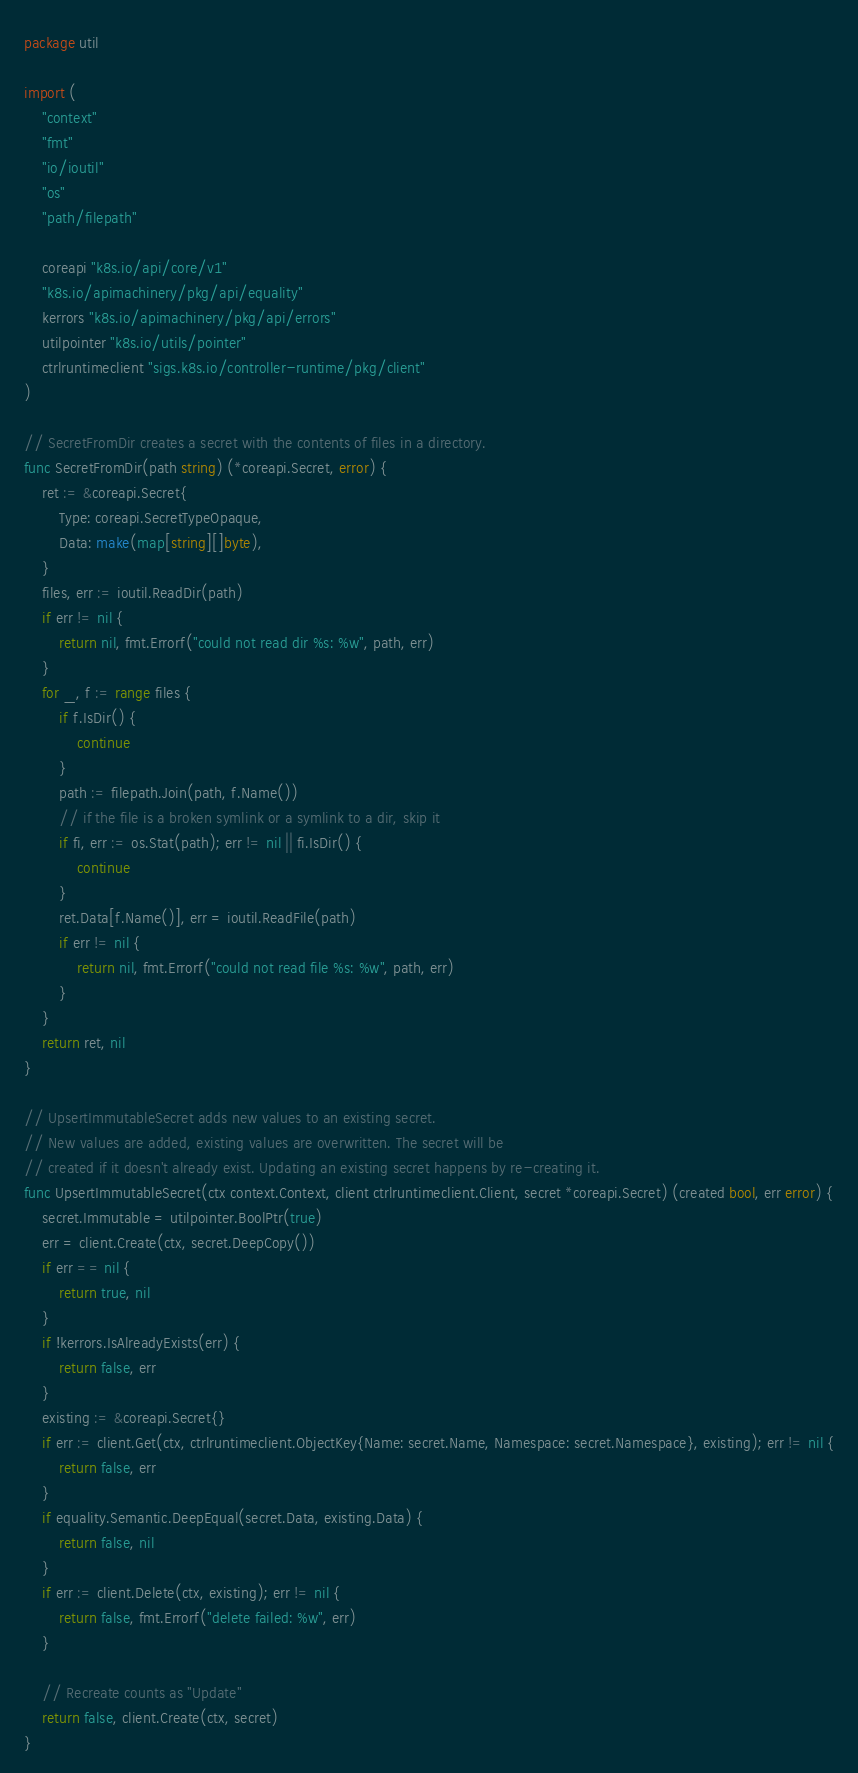Convert code to text. <code><loc_0><loc_0><loc_500><loc_500><_Go_>package util

import (
	"context"
	"fmt"
	"io/ioutil"
	"os"
	"path/filepath"

	coreapi "k8s.io/api/core/v1"
	"k8s.io/apimachinery/pkg/api/equality"
	kerrors "k8s.io/apimachinery/pkg/api/errors"
	utilpointer "k8s.io/utils/pointer"
	ctrlruntimeclient "sigs.k8s.io/controller-runtime/pkg/client"
)

// SecretFromDir creates a secret with the contents of files in a directory.
func SecretFromDir(path string) (*coreapi.Secret, error) {
	ret := &coreapi.Secret{
		Type: coreapi.SecretTypeOpaque,
		Data: make(map[string][]byte),
	}
	files, err := ioutil.ReadDir(path)
	if err != nil {
		return nil, fmt.Errorf("could not read dir %s: %w", path, err)
	}
	for _, f := range files {
		if f.IsDir() {
			continue
		}
		path := filepath.Join(path, f.Name())
		// if the file is a broken symlink or a symlink to a dir, skip it
		if fi, err := os.Stat(path); err != nil || fi.IsDir() {
			continue
		}
		ret.Data[f.Name()], err = ioutil.ReadFile(path)
		if err != nil {
			return nil, fmt.Errorf("could not read file %s: %w", path, err)
		}
	}
	return ret, nil
}

// UpsertImmutableSecret adds new values to an existing secret.
// New values are added, existing values are overwritten. The secret will be
// created if it doesn't already exist. Updating an existing secret happens by re-creating it.
func UpsertImmutableSecret(ctx context.Context, client ctrlruntimeclient.Client, secret *coreapi.Secret) (created bool, err error) {
	secret.Immutable = utilpointer.BoolPtr(true)
	err = client.Create(ctx, secret.DeepCopy())
	if err == nil {
		return true, nil
	}
	if !kerrors.IsAlreadyExists(err) {
		return false, err
	}
	existing := &coreapi.Secret{}
	if err := client.Get(ctx, ctrlruntimeclient.ObjectKey{Name: secret.Name, Namespace: secret.Namespace}, existing); err != nil {
		return false, err
	}
	if equality.Semantic.DeepEqual(secret.Data, existing.Data) {
		return false, nil
	}
	if err := client.Delete(ctx, existing); err != nil {
		return false, fmt.Errorf("delete failed: %w", err)
	}

	// Recreate counts as "Update"
	return false, client.Create(ctx, secret)
}
</code> 